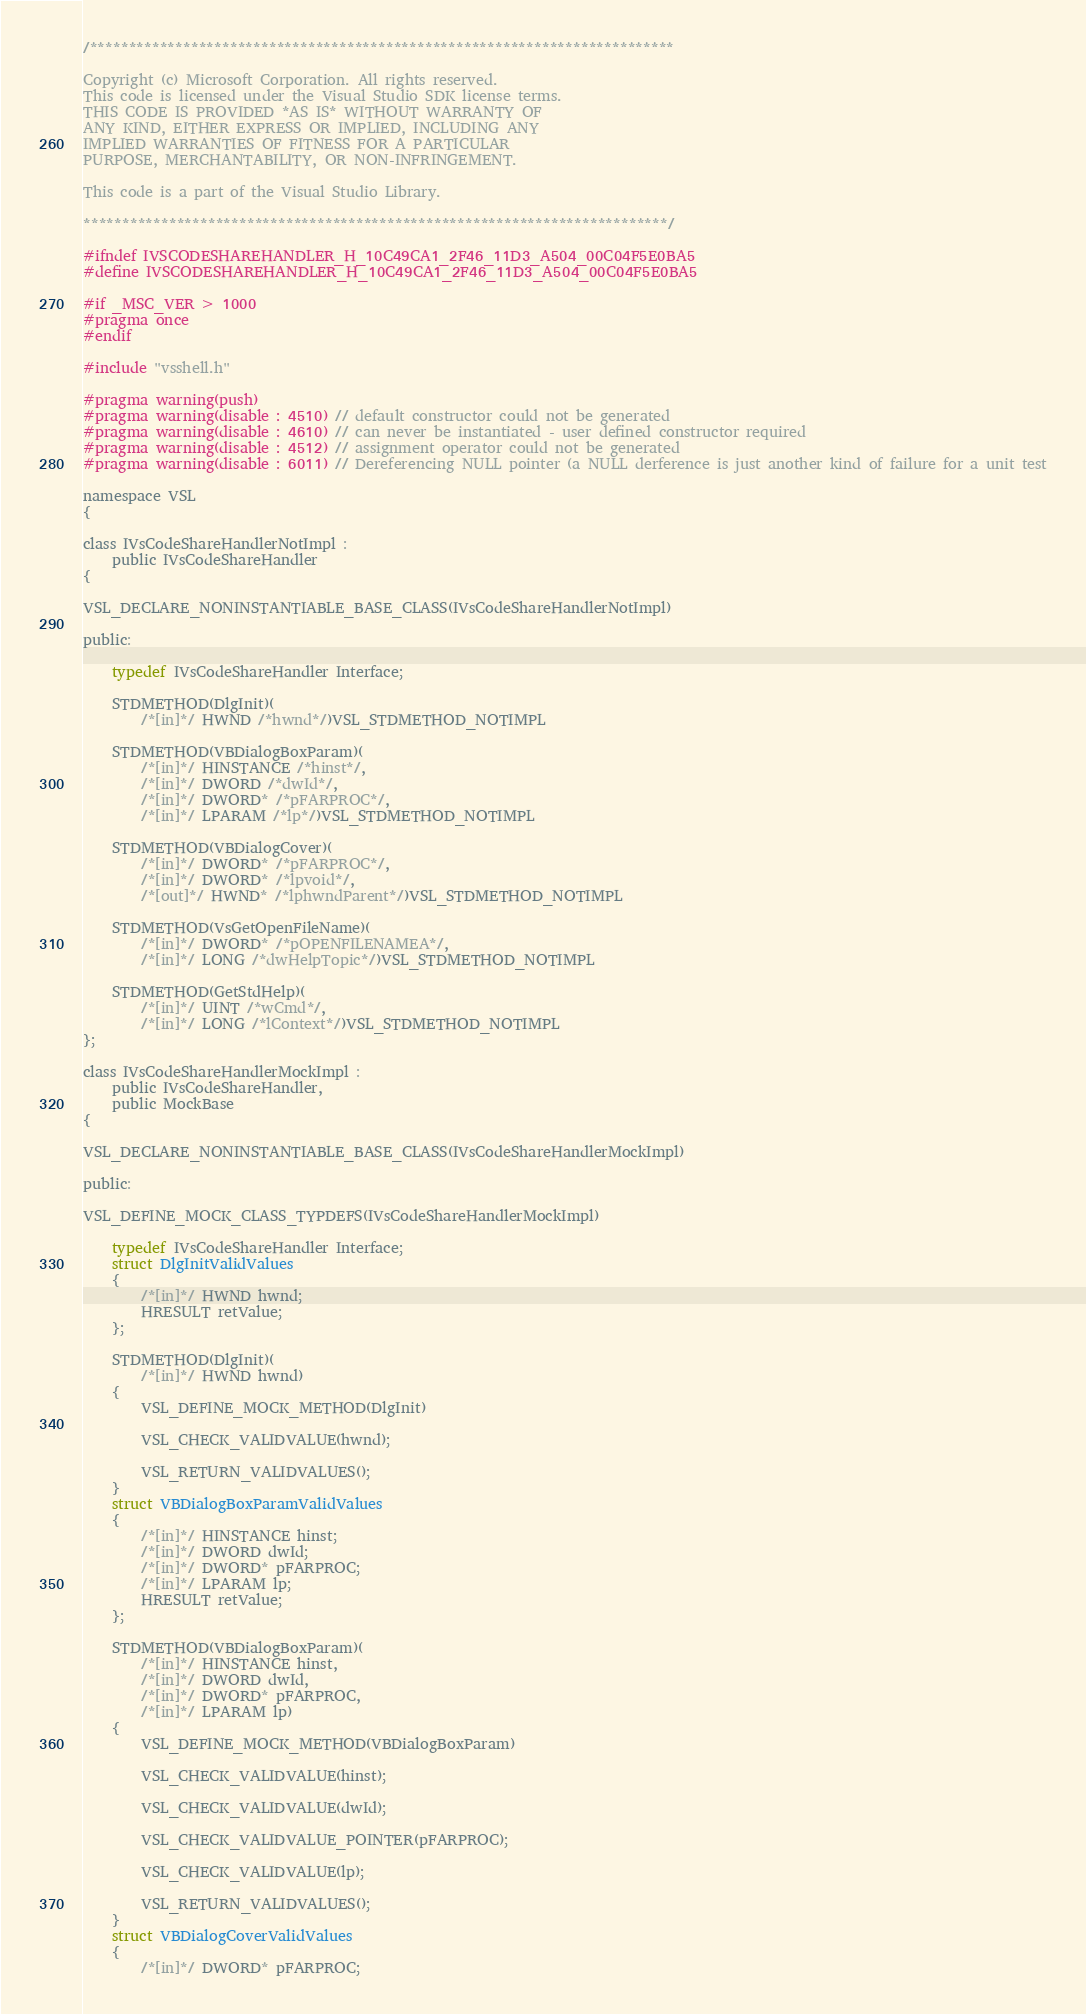Convert code to text. <code><loc_0><loc_0><loc_500><loc_500><_C_>/***************************************************************************

Copyright (c) Microsoft Corporation. All rights reserved.
This code is licensed under the Visual Studio SDK license terms.
THIS CODE IS PROVIDED *AS IS* WITHOUT WARRANTY OF
ANY KIND, EITHER EXPRESS OR IMPLIED, INCLUDING ANY
IMPLIED WARRANTIES OF FITNESS FOR A PARTICULAR
PURPOSE, MERCHANTABILITY, OR NON-INFRINGEMENT.

This code is a part of the Visual Studio Library.

***************************************************************************/

#ifndef IVSCODESHAREHANDLER_H_10C49CA1_2F46_11D3_A504_00C04F5E0BA5
#define IVSCODESHAREHANDLER_H_10C49CA1_2F46_11D3_A504_00C04F5E0BA5

#if _MSC_VER > 1000
#pragma once
#endif

#include "vsshell.h"

#pragma warning(push)
#pragma warning(disable : 4510) // default constructor could not be generated
#pragma warning(disable : 4610) // can never be instantiated - user defined constructor required
#pragma warning(disable : 4512) // assignment operator could not be generated
#pragma warning(disable : 6011) // Dereferencing NULL pointer (a NULL derference is just another kind of failure for a unit test

namespace VSL
{

class IVsCodeShareHandlerNotImpl :
	public IVsCodeShareHandler
{

VSL_DECLARE_NONINSTANTIABLE_BASE_CLASS(IVsCodeShareHandlerNotImpl)

public:

	typedef IVsCodeShareHandler Interface;

	STDMETHOD(DlgInit)(
		/*[in]*/ HWND /*hwnd*/)VSL_STDMETHOD_NOTIMPL

	STDMETHOD(VBDialogBoxParam)(
		/*[in]*/ HINSTANCE /*hinst*/,
		/*[in]*/ DWORD /*dwId*/,
		/*[in]*/ DWORD* /*pFARPROC*/,
		/*[in]*/ LPARAM /*lp*/)VSL_STDMETHOD_NOTIMPL

	STDMETHOD(VBDialogCover)(
		/*[in]*/ DWORD* /*pFARPROC*/,
		/*[in]*/ DWORD* /*lpvoid*/,
		/*[out]*/ HWND* /*lphwndParent*/)VSL_STDMETHOD_NOTIMPL

	STDMETHOD(VsGetOpenFileName)(
		/*[in]*/ DWORD* /*pOPENFILENAMEA*/,
		/*[in]*/ LONG /*dwHelpTopic*/)VSL_STDMETHOD_NOTIMPL

	STDMETHOD(GetStdHelp)(
		/*[in]*/ UINT /*wCmd*/,
		/*[in]*/ LONG /*lContext*/)VSL_STDMETHOD_NOTIMPL
};

class IVsCodeShareHandlerMockImpl :
	public IVsCodeShareHandler,
	public MockBase
{

VSL_DECLARE_NONINSTANTIABLE_BASE_CLASS(IVsCodeShareHandlerMockImpl)

public:

VSL_DEFINE_MOCK_CLASS_TYPDEFS(IVsCodeShareHandlerMockImpl)

	typedef IVsCodeShareHandler Interface;
	struct DlgInitValidValues
	{
		/*[in]*/ HWND hwnd;
		HRESULT retValue;
	};

	STDMETHOD(DlgInit)(
		/*[in]*/ HWND hwnd)
	{
		VSL_DEFINE_MOCK_METHOD(DlgInit)

		VSL_CHECK_VALIDVALUE(hwnd);

		VSL_RETURN_VALIDVALUES();
	}
	struct VBDialogBoxParamValidValues
	{
		/*[in]*/ HINSTANCE hinst;
		/*[in]*/ DWORD dwId;
		/*[in]*/ DWORD* pFARPROC;
		/*[in]*/ LPARAM lp;
		HRESULT retValue;
	};

	STDMETHOD(VBDialogBoxParam)(
		/*[in]*/ HINSTANCE hinst,
		/*[in]*/ DWORD dwId,
		/*[in]*/ DWORD* pFARPROC,
		/*[in]*/ LPARAM lp)
	{
		VSL_DEFINE_MOCK_METHOD(VBDialogBoxParam)

		VSL_CHECK_VALIDVALUE(hinst);

		VSL_CHECK_VALIDVALUE(dwId);

		VSL_CHECK_VALIDVALUE_POINTER(pFARPROC);

		VSL_CHECK_VALIDVALUE(lp);

		VSL_RETURN_VALIDVALUES();
	}
	struct VBDialogCoverValidValues
	{
		/*[in]*/ DWORD* pFARPROC;</code> 